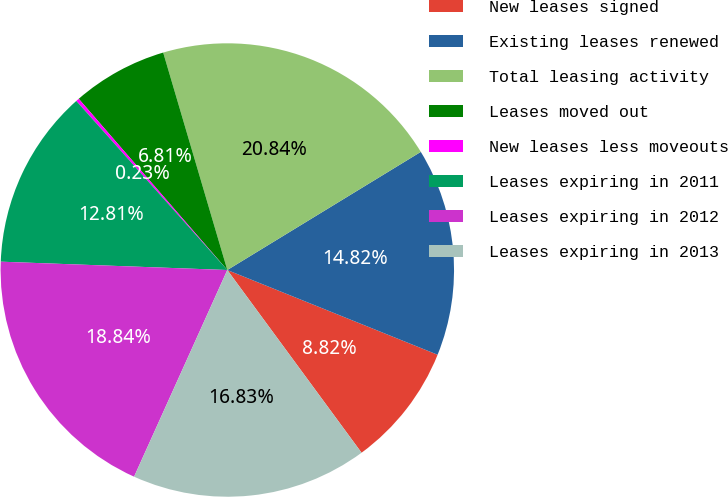<chart> <loc_0><loc_0><loc_500><loc_500><pie_chart><fcel>New leases signed<fcel>Existing leases renewed<fcel>Total leasing activity<fcel>Leases moved out<fcel>New leases less moveouts<fcel>Leases expiring in 2011<fcel>Leases expiring in 2012<fcel>Leases expiring in 2013<nl><fcel>8.82%<fcel>14.82%<fcel>20.84%<fcel>6.81%<fcel>0.23%<fcel>12.81%<fcel>18.84%<fcel>16.83%<nl></chart> 